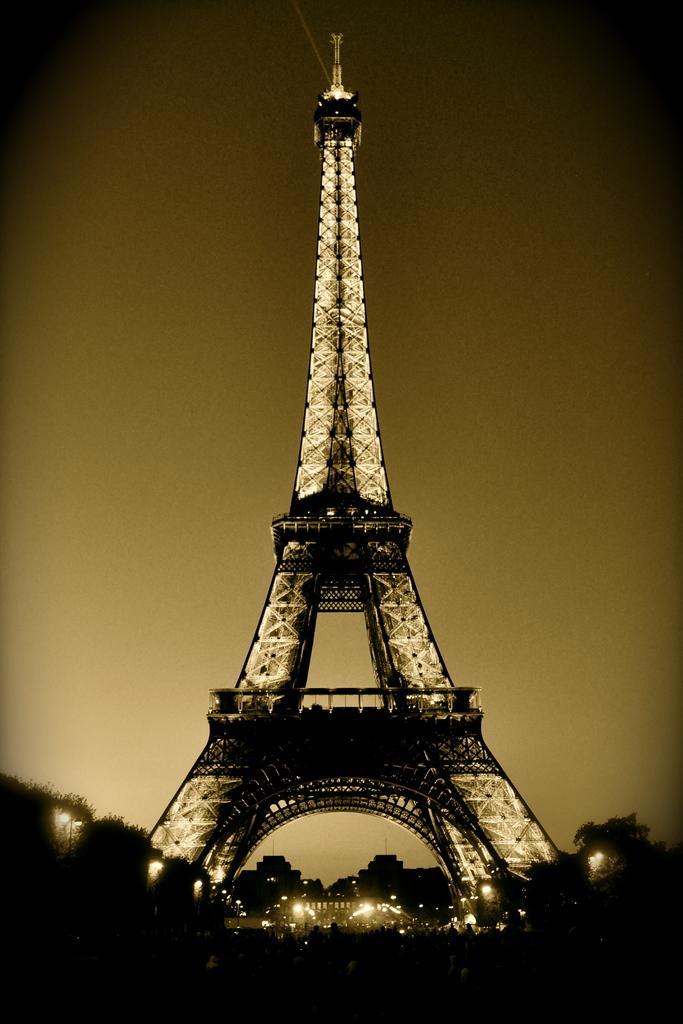Describe this image in one or two sentences. It is an Eiffel tower in the nighttime with lights. It is a black and white image. 